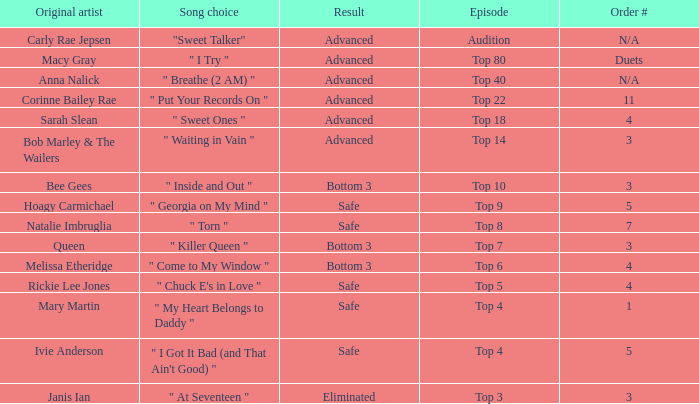What's the original artist of the song performed in the top 3 episode? Janis Ian. 